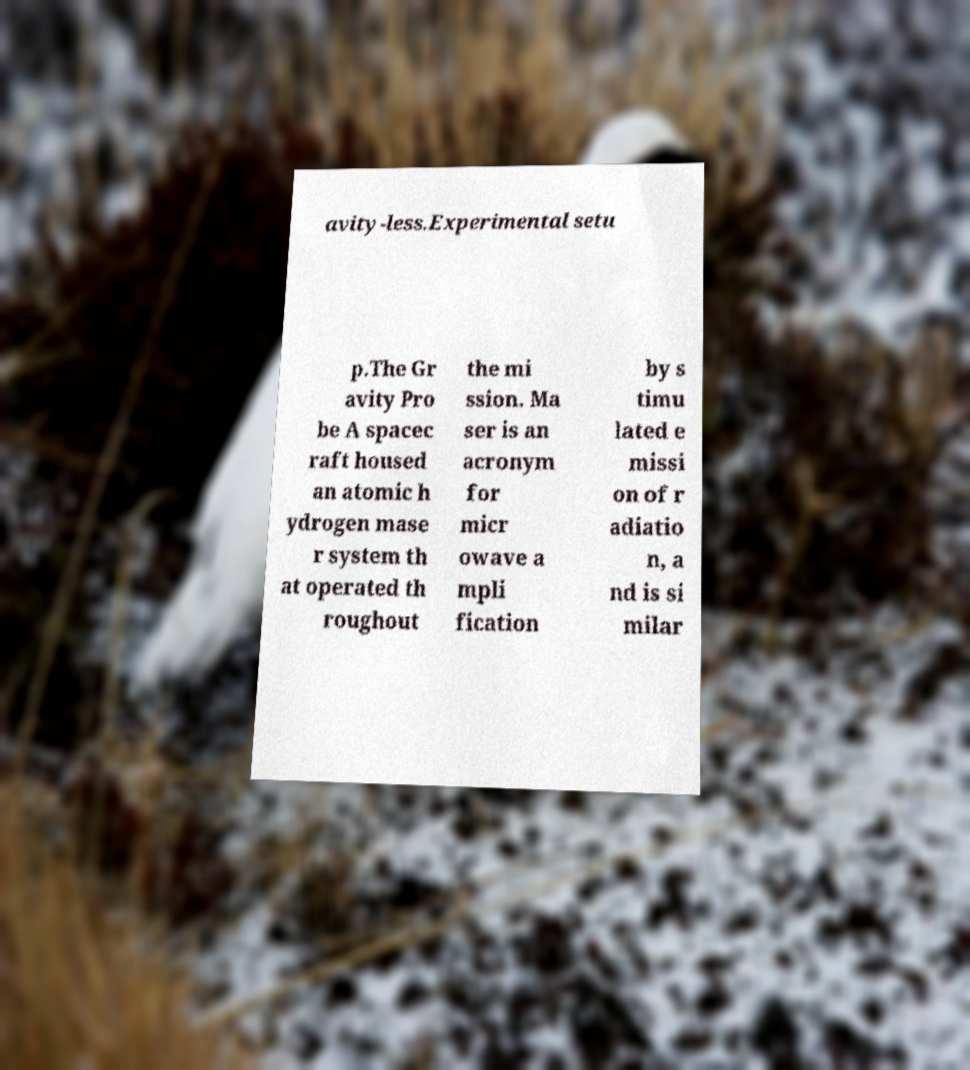What messages or text are displayed in this image? I need them in a readable, typed format. avity-less.Experimental setu p.The Gr avity Pro be A spacec raft housed an atomic h ydrogen mase r system th at operated th roughout the mi ssion. Ma ser is an acronym for micr owave a mpli fication by s timu lated e missi on of r adiatio n, a nd is si milar 